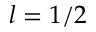<formula> <loc_0><loc_0><loc_500><loc_500>l = 1 / 2</formula> 